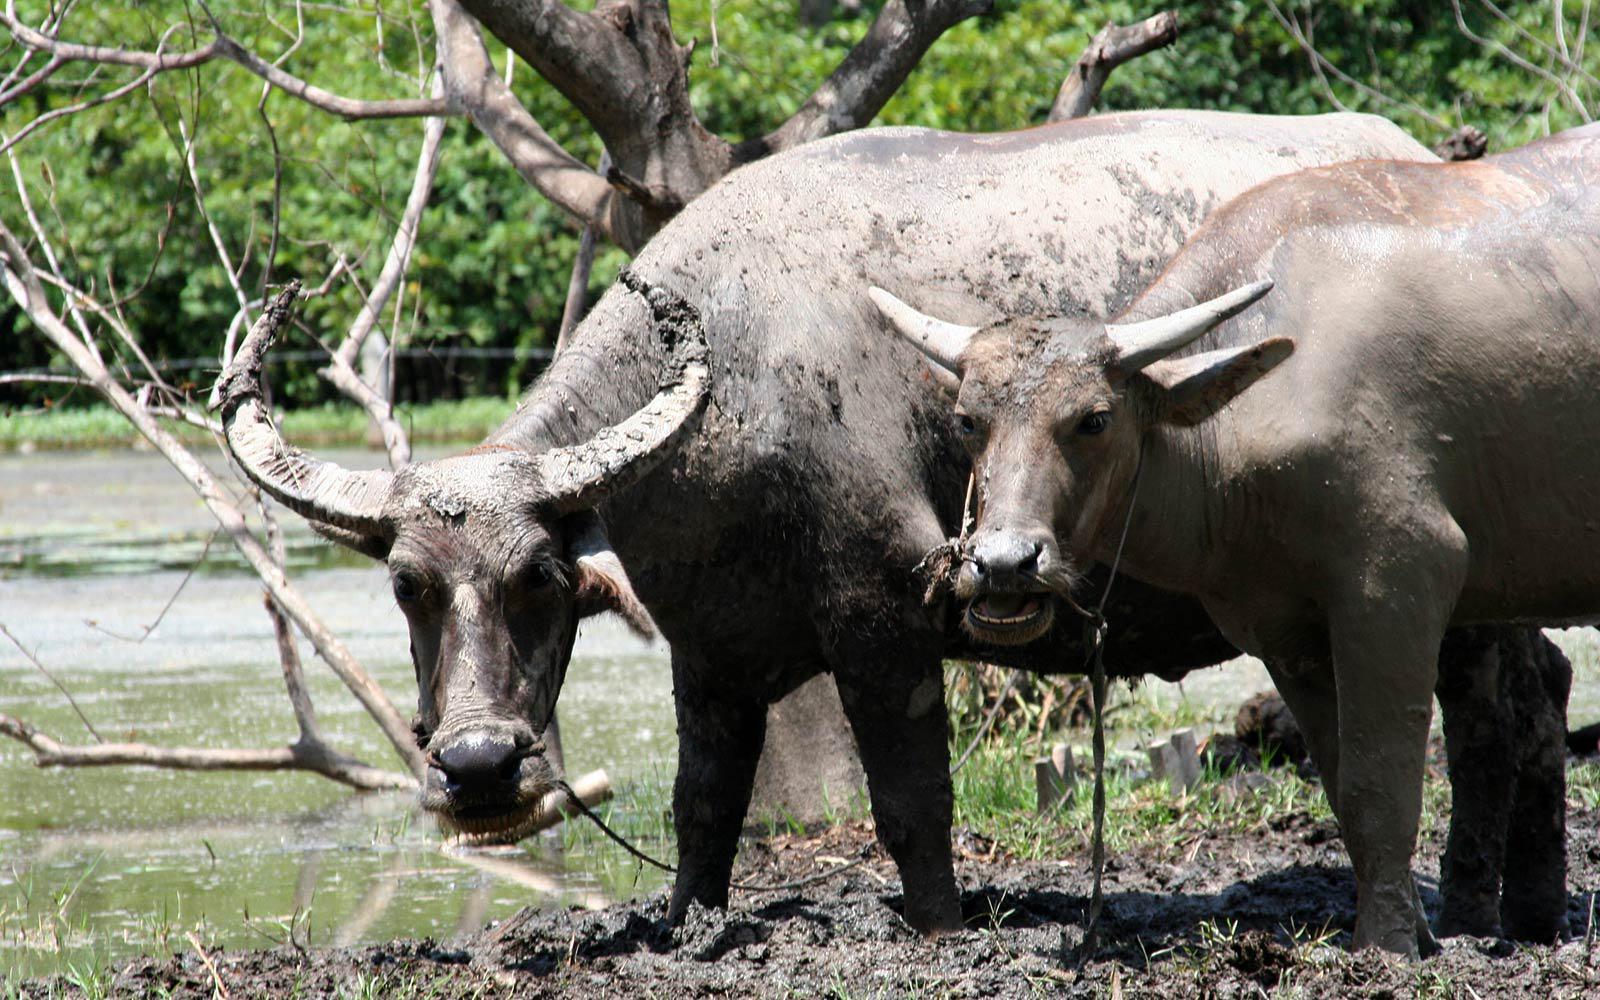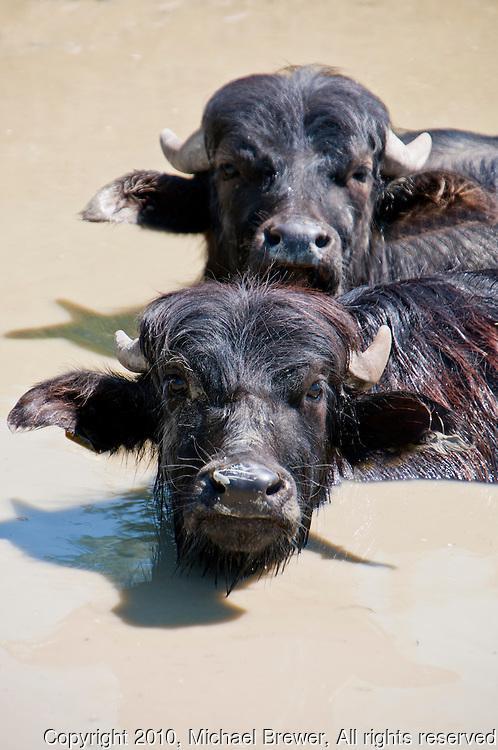The first image is the image on the left, the second image is the image on the right. Evaluate the accuracy of this statement regarding the images: "One image shows at least two water buffalo in water up to their chins.". Is it true? Answer yes or no. Yes. The first image is the image on the left, the second image is the image on the right. Analyze the images presented: Is the assertion "The left image contains exactly two water buffaloes." valid? Answer yes or no. Yes. 